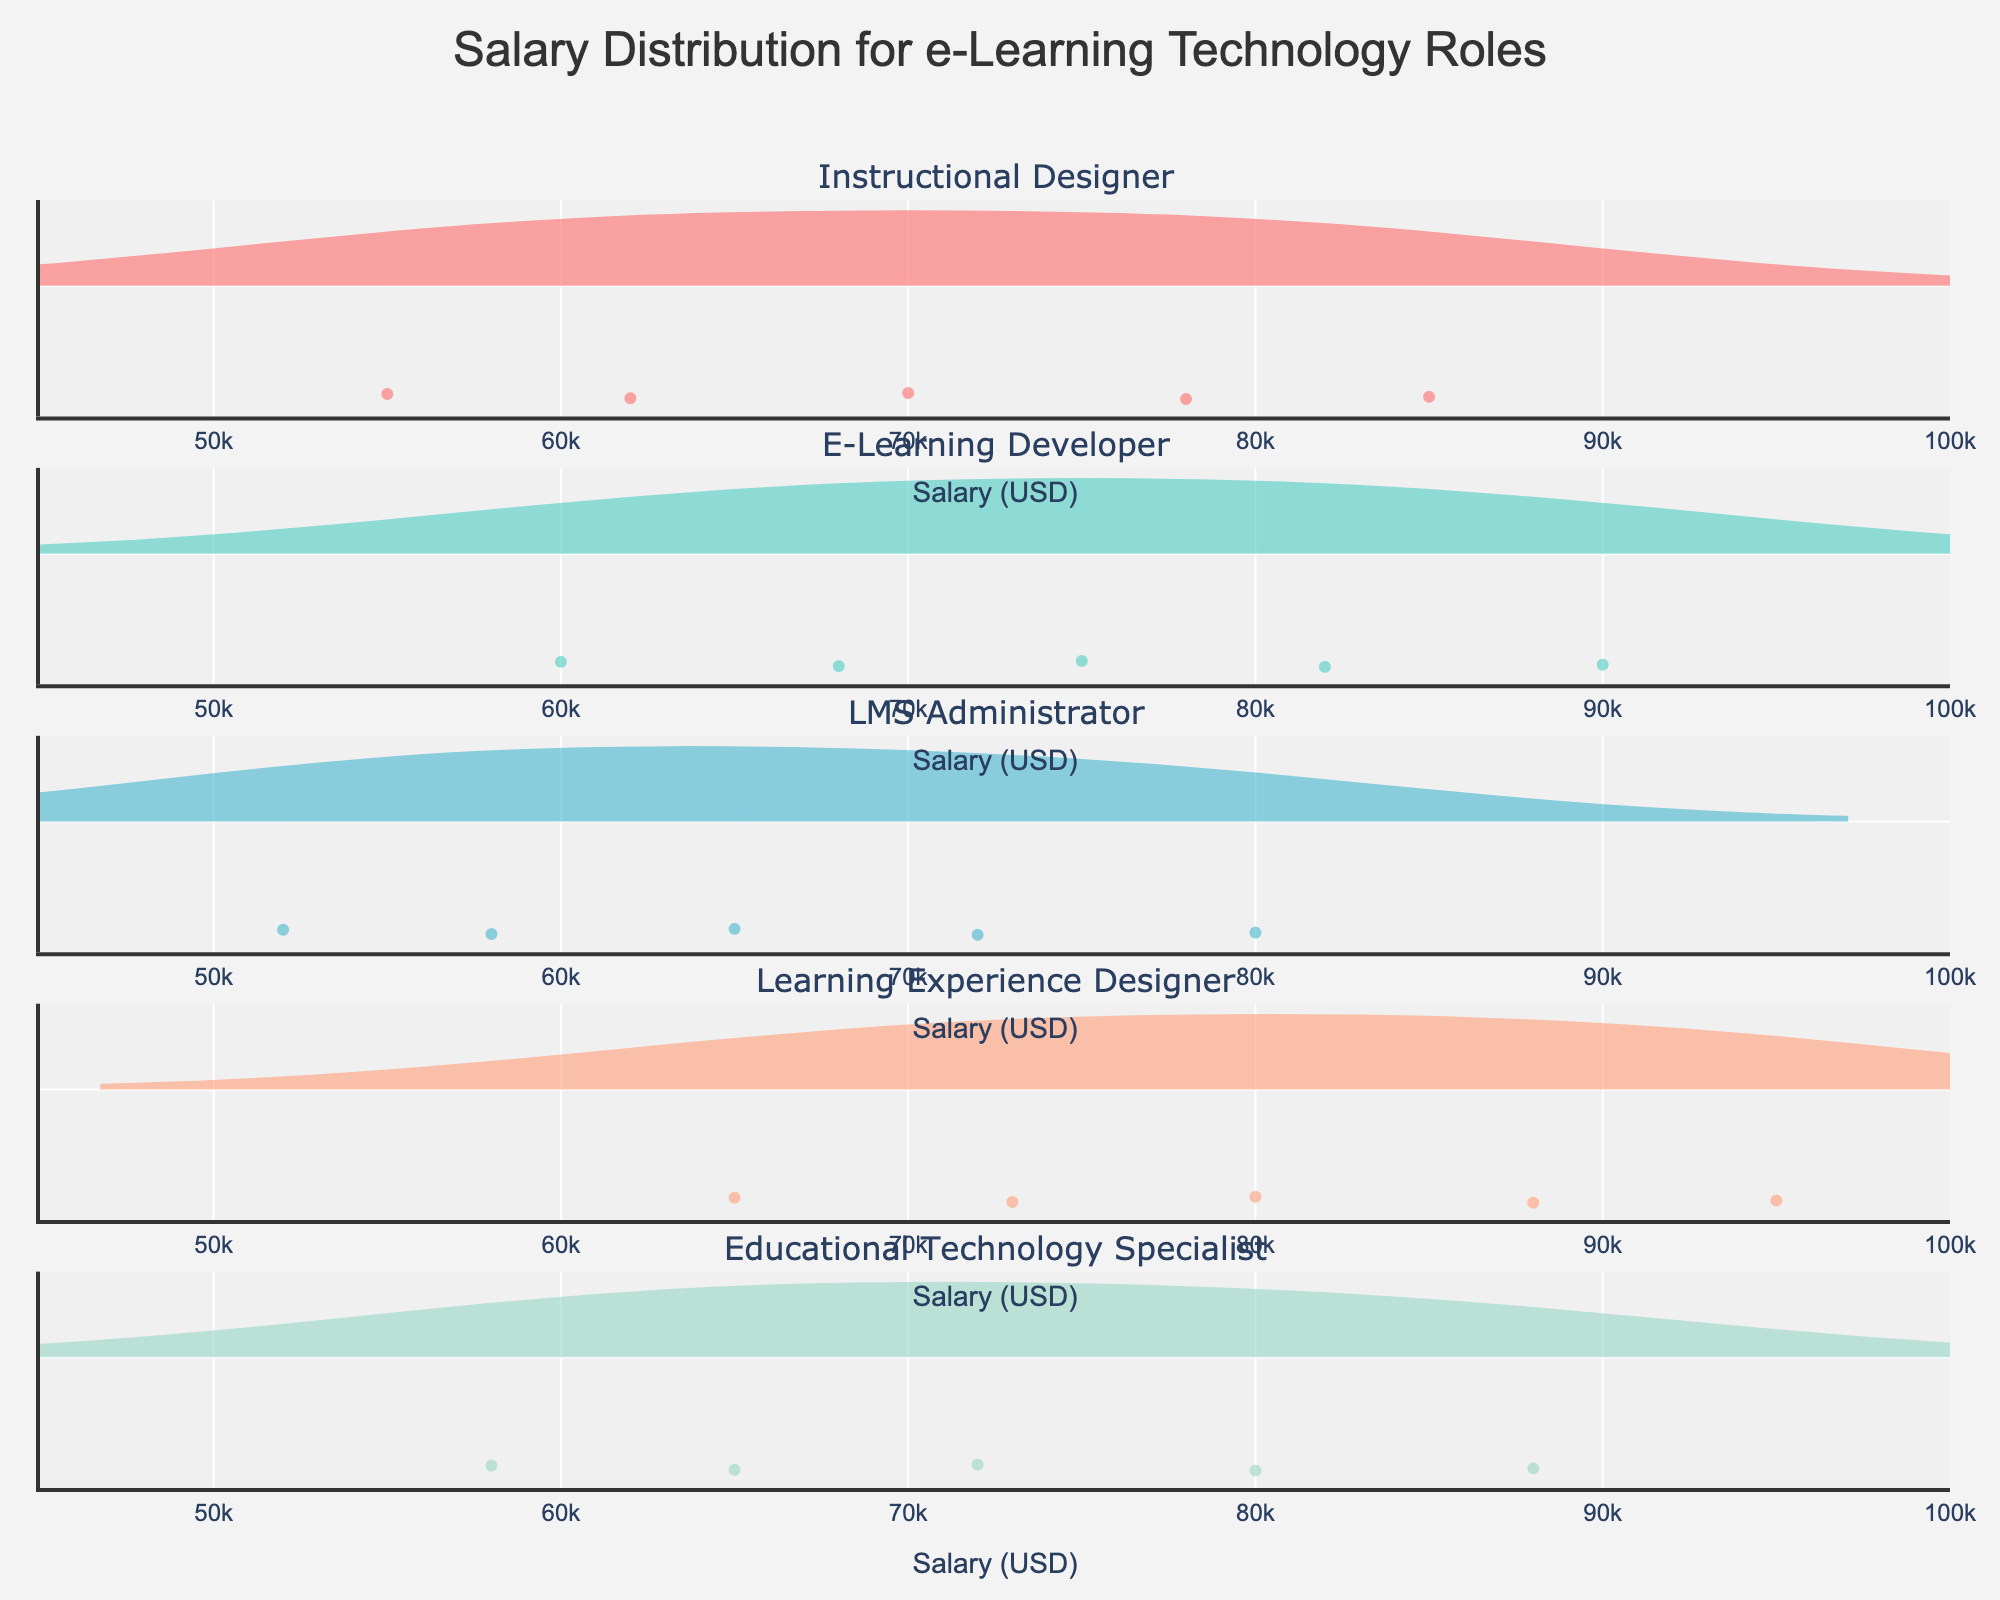What is the title of the plot? The title is located at the top center of the plot and is typically formatted in a larger font size to stand out. It helps in understanding the subject of the graph.
Answer: Salary Distribution for e-Learning Technology Roles Which role has the highest average salary based on the density plot? To identify the role with the highest average salary, look at the meanline for each role within the density plot. The role with the meanline positioned further to the right has the highest average salary.
Answer: Learning Experience Designer What is the salary range for the LMS Administrator role? To determine the salary range, locate the endpoints of the violin plot for the LMS Administrator role and note the minimum and maximum values on the x-axis.
Answer: 52000 to 80000 How does the variability in salaries for the E-Learning Developer compare to that of the Instructional Designer? Examine the spread of the violin plots for both E-Learning Developer and Instructional Designer on the x-axis. A wider spread indicates greater variability in salaries.
Answer: E-Learning Developer has greater variability Which role has the most number of salary data points in the plot? Observe the density of points along the x-axis within each violin plot. The plot with the densest concentration of individual points has the most data points.
Answer: All roles have an equal number of data points Is there a significant overlap in salary range between Learning Experience Designer and Educational Technology Specialist? Compare the endpoints and spread of the violin plots for Learning Experience Designer and Educational Technology Specialist. Overlap in the range on the x-axis indicates similarity in salary ranges.
Answer: Yes, there is overlap What is the median salary for the Instructional Designer role? The median salary is represented by the meanline visible in the middle of the violin plot for Instructional Designer, which is positioned at the median value on the x-axis.
Answer: 70000 